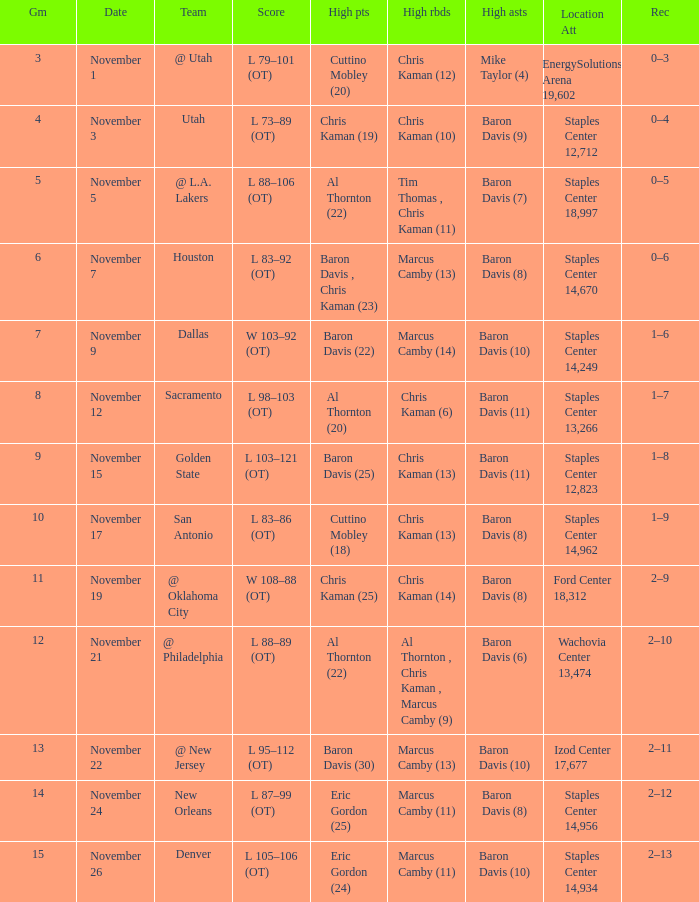Name the high points for the date of november 24 Eric Gordon (25). 